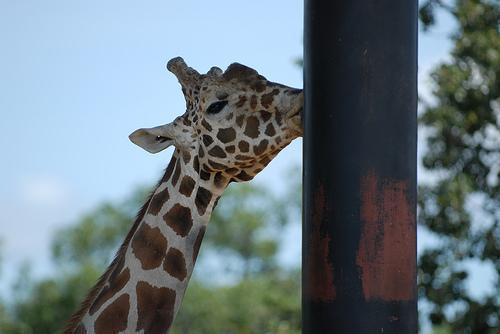How many giraffes are there?
Give a very brief answer. 1. 